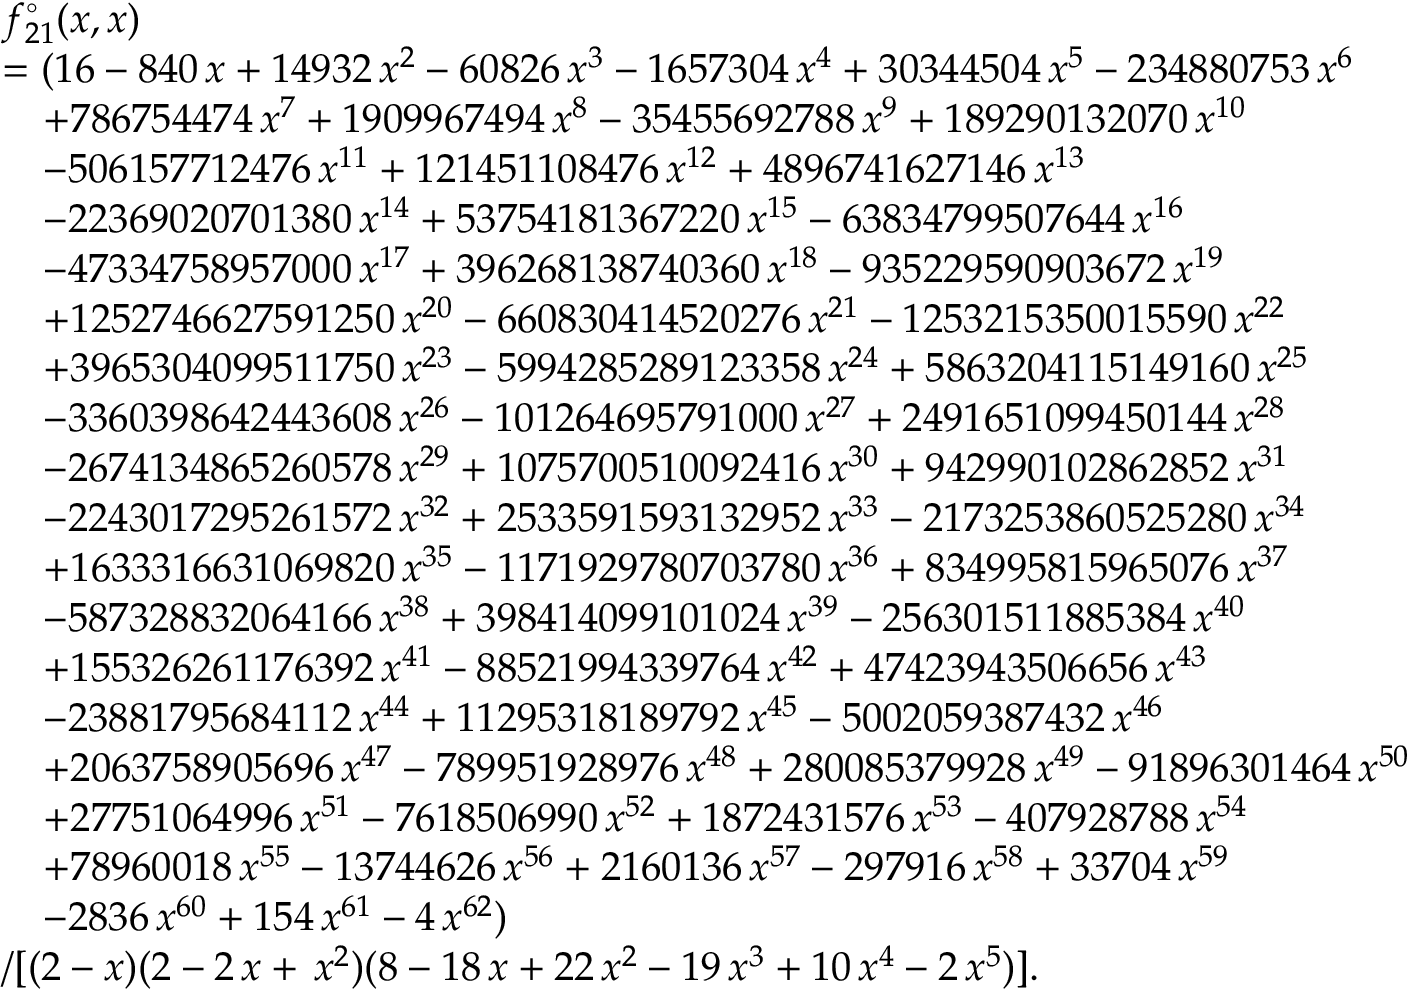Convert formula to latex. <formula><loc_0><loc_0><loc_500><loc_500>\begin{array} { r l } & { f _ { 2 1 } ^ { \circ } ( x , x ) } \\ & { = ( 1 6 - 8 4 0 \, x + 1 4 9 3 2 \, x ^ { 2 } - 6 0 8 2 6 \, x ^ { 3 } - 1 6 5 7 3 0 4 \, x ^ { 4 } + 3 0 3 4 4 5 0 4 \, x ^ { 5 } - 2 3 4 8 8 0 7 5 3 \, x ^ { 6 } } \\ & { \quad + 7 8 6 7 5 4 4 7 4 \, x ^ { 7 } + 1 9 0 9 9 6 7 4 9 4 \, x ^ { 8 } - 3 5 4 5 5 6 9 2 7 8 8 \, x ^ { 9 } + 1 8 9 2 9 0 1 3 2 0 7 0 \, x ^ { 1 0 } } \\ & { \quad - 5 0 6 1 5 7 7 1 2 4 7 6 \, x ^ { 1 1 } + 1 2 1 4 5 1 1 0 8 4 7 6 \, x ^ { 1 2 } + 4 8 9 6 7 4 1 6 2 7 1 4 6 \, x ^ { 1 3 } } \\ & { \quad - 2 2 3 6 9 0 2 0 7 0 1 3 8 0 \, x ^ { 1 4 } + 5 3 7 5 4 1 8 1 3 6 7 2 2 0 \, x ^ { 1 5 } - 6 3 8 3 4 7 9 9 5 0 7 6 4 4 \, x ^ { 1 6 } } \\ & { \quad - 4 7 3 3 4 7 5 8 9 5 7 0 0 0 \, x ^ { 1 7 } + 3 9 6 2 6 8 1 3 8 7 4 0 3 6 0 \, x ^ { 1 8 } - 9 3 5 2 2 9 5 9 0 9 0 3 6 7 2 \, x ^ { 1 9 } } \\ & { \quad + 1 2 5 2 7 4 6 6 2 7 5 9 1 2 5 0 \, x ^ { 2 0 } - 6 6 0 8 3 0 4 1 4 5 2 0 2 7 6 \, x ^ { 2 1 } - 1 2 5 3 2 1 5 3 5 0 0 1 5 5 9 0 \, x ^ { 2 2 } } \\ & { \quad + 3 9 6 5 3 0 4 0 9 9 5 1 1 7 5 0 \, x ^ { 2 3 } - 5 9 9 4 2 8 5 2 8 9 1 2 3 3 5 8 \, x ^ { 2 4 } + 5 8 6 3 2 0 4 1 1 5 1 4 9 1 6 0 \, x ^ { 2 5 } } \\ & { \quad - 3 3 6 0 3 9 8 6 4 2 4 4 3 6 0 8 \, x ^ { 2 6 } - 1 0 1 2 6 4 6 9 5 7 9 1 0 0 0 \, x ^ { 2 7 } + 2 4 9 1 6 5 1 0 9 9 4 5 0 1 4 4 \, x ^ { 2 8 } } \\ & { \quad - 2 6 7 4 1 3 4 8 6 5 2 6 0 5 7 8 \, x ^ { 2 9 } + 1 0 7 5 7 0 0 5 1 0 0 9 2 4 1 6 \, x ^ { 3 0 } + 9 4 2 9 9 0 1 0 2 8 6 2 8 5 2 \, x ^ { 3 1 } } \\ & { \quad - 2 2 4 3 0 1 7 2 9 5 2 6 1 5 7 2 \, x ^ { 3 2 } + 2 5 3 3 5 9 1 5 9 3 1 3 2 9 5 2 \, x ^ { 3 3 } - 2 1 7 3 2 5 3 8 6 0 5 2 5 2 8 0 \, x ^ { 3 4 } } \\ & { \quad + 1 6 3 3 3 1 6 6 3 1 0 6 9 8 2 0 \, x ^ { 3 5 } - 1 1 7 1 9 2 9 7 8 0 7 0 3 7 8 0 \, x ^ { 3 6 } + 8 3 4 9 9 5 8 1 5 9 6 5 0 7 6 \, x ^ { 3 7 } } \\ & { \quad - 5 8 7 3 2 8 8 3 2 0 6 4 1 6 6 \, x ^ { 3 8 } + 3 9 8 4 1 4 0 9 9 1 0 1 0 2 4 \, x ^ { 3 9 } - 2 5 6 3 0 1 5 1 1 8 8 5 3 8 4 \, x ^ { 4 0 } } \\ & { \quad + 1 5 5 3 2 6 2 6 1 1 7 6 3 9 2 \, x ^ { 4 1 } - 8 8 5 2 1 9 9 4 3 3 9 7 6 4 \, x ^ { 4 2 } + 4 7 4 2 3 9 4 3 5 0 6 6 5 6 \, x ^ { 4 3 } } \\ & { \quad - 2 3 8 8 1 7 9 5 6 8 4 1 1 2 \, x ^ { 4 4 } + 1 1 2 9 5 3 1 8 1 8 9 7 9 2 \, x ^ { 4 5 } - 5 0 0 2 0 5 9 3 8 7 4 3 2 \, x ^ { 4 6 } } \\ & { \quad + 2 0 6 3 7 5 8 9 0 5 6 9 6 \, x ^ { 4 7 } - 7 8 9 9 5 1 9 2 8 9 7 6 \, x ^ { 4 8 } + 2 8 0 0 8 5 3 7 9 9 2 8 \, x ^ { 4 9 } - 9 1 8 9 6 3 0 1 4 6 4 \, x ^ { 5 0 } } \\ & { \quad + 2 7 7 5 1 0 6 4 9 9 6 \, x ^ { 5 1 } - 7 6 1 8 5 0 6 9 9 0 \, x ^ { 5 2 } + 1 8 7 2 4 3 1 5 7 6 \, x ^ { 5 3 } - 4 0 7 9 2 8 7 8 8 \, x ^ { 5 4 } } \\ & { \quad + 7 8 9 6 0 0 1 8 \, x ^ { 5 5 } - 1 3 7 4 4 6 2 6 \, x ^ { 5 6 } + 2 1 6 0 1 3 6 \, x ^ { 5 7 } - 2 9 7 9 1 6 \, x ^ { 5 8 } + 3 3 7 0 4 \, x ^ { 5 9 } } \\ & { \quad - 2 8 3 6 \, x ^ { 6 0 } + 1 5 4 \, x ^ { 6 1 } - 4 \, x ^ { 6 2 } ) } \\ & { / [ ( 2 - x ) ( 2 - 2 \, x + \, x ^ { 2 } ) ( 8 - 1 8 \, x + 2 2 \, x ^ { 2 } - 1 9 \, x ^ { 3 } + 1 0 \, x ^ { 4 } - 2 \, x ^ { 5 } ) ] . } \end{array}</formula> 